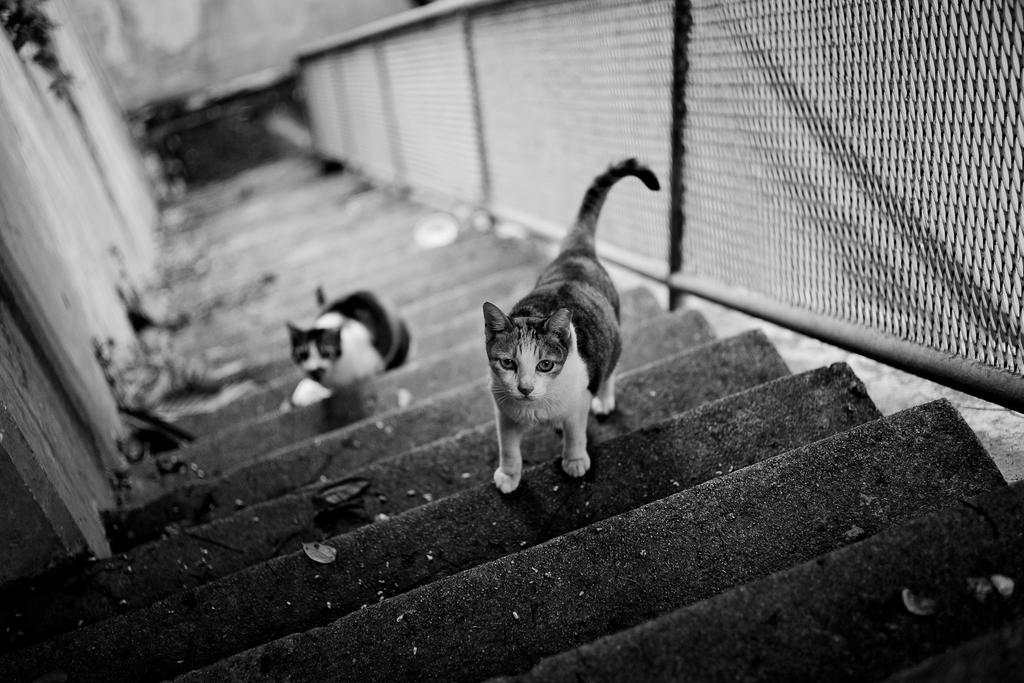What is the color scheme of the image? The image is black and white. How many cats are present in the image? There are two cats in the image. Where are the cats located in the image? The cats are on the steps. What is beside the steps in the image? There is a mesh railing beside the steps. What can be seen on the left side of the image? There is a wall on the left side of the image. Can you see a snail crawling on the wall in the image? There is no snail present in the image; it only features two cats on the steps, a mesh railing, and a wall. What type of stitch is used to create the cats in the image? The image is not a drawing or a stitched creation; it is a photograph, so there is no stitching involved. 